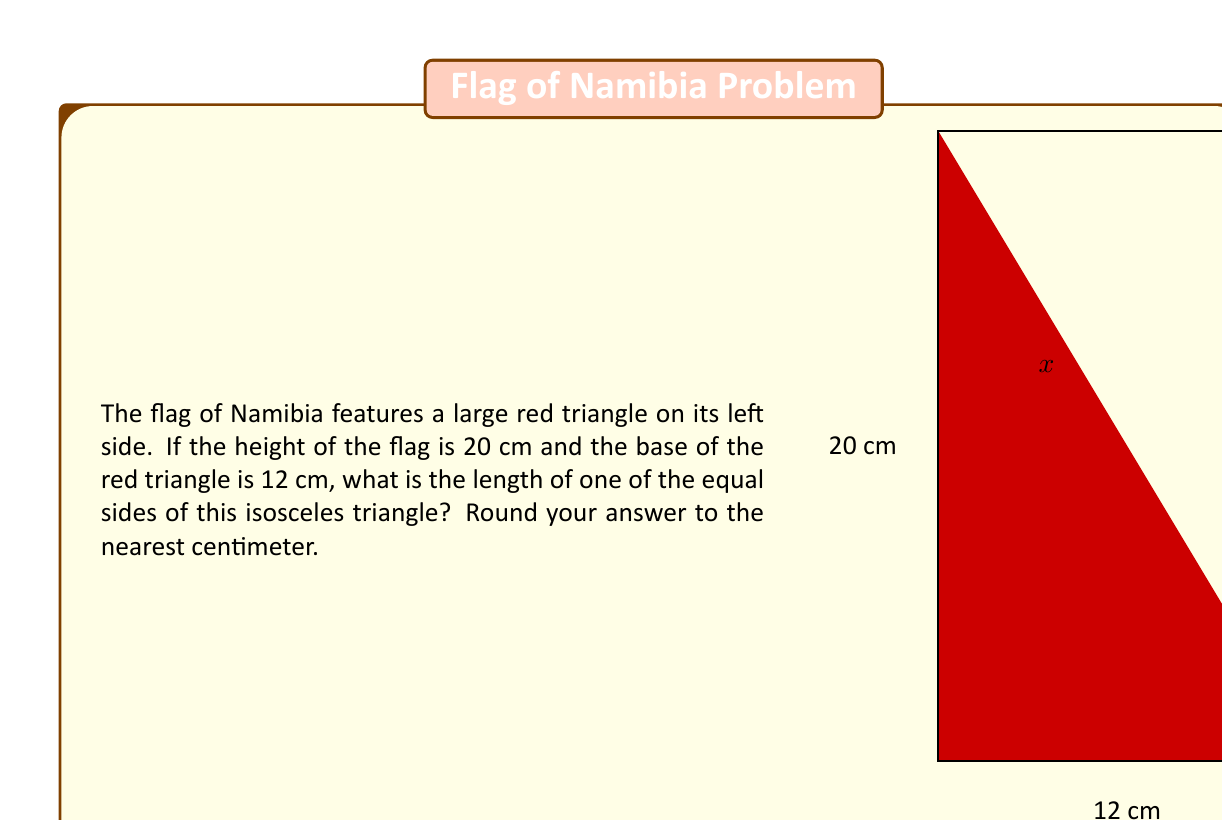Show me your answer to this math problem. Let's approach this step-by-step:

1) The red triangle in the Namibian flag is an isosceles right-angled triangle. We know the base (12 cm) and the height (20 cm).

2) Let's denote the length of the equal sides as $x$.

3) We can use the Pythagorean theorem to solve for $x$:

   $$x^2 = 12^2 + 20^2$$

4) Simplify:
   $$x^2 = 144 + 400 = 544$$

5) Take the square root of both sides:
   $$x = \sqrt{544}$$

6) Simplify the square root:
   $$x = 4\sqrt{34} \approx 23.32 \text{ cm}$$

7) Rounding to the nearest centimeter:
   $$x \approx 23 \text{ cm}$$

This problem combines geometry with a cultural element, making it relevant for a librarian aiming to boost awareness about Africa through the symbolism in African flags.
Answer: 23 cm 